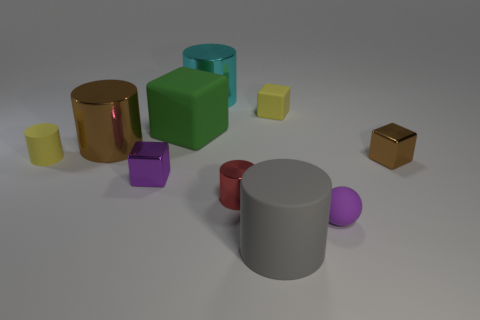Subtract all small blocks. How many blocks are left? 1 Subtract 1 blocks. How many blocks are left? 3 Subtract all yellow cubes. How many cubes are left? 3 Subtract all yellow cylinders. Subtract all purple balls. How many cylinders are left? 4 Subtract all cubes. How many objects are left? 6 Subtract all small yellow rubber objects. Subtract all large brown metal objects. How many objects are left? 7 Add 8 green blocks. How many green blocks are left? 9 Add 7 brown objects. How many brown objects exist? 9 Subtract 0 cyan spheres. How many objects are left? 10 